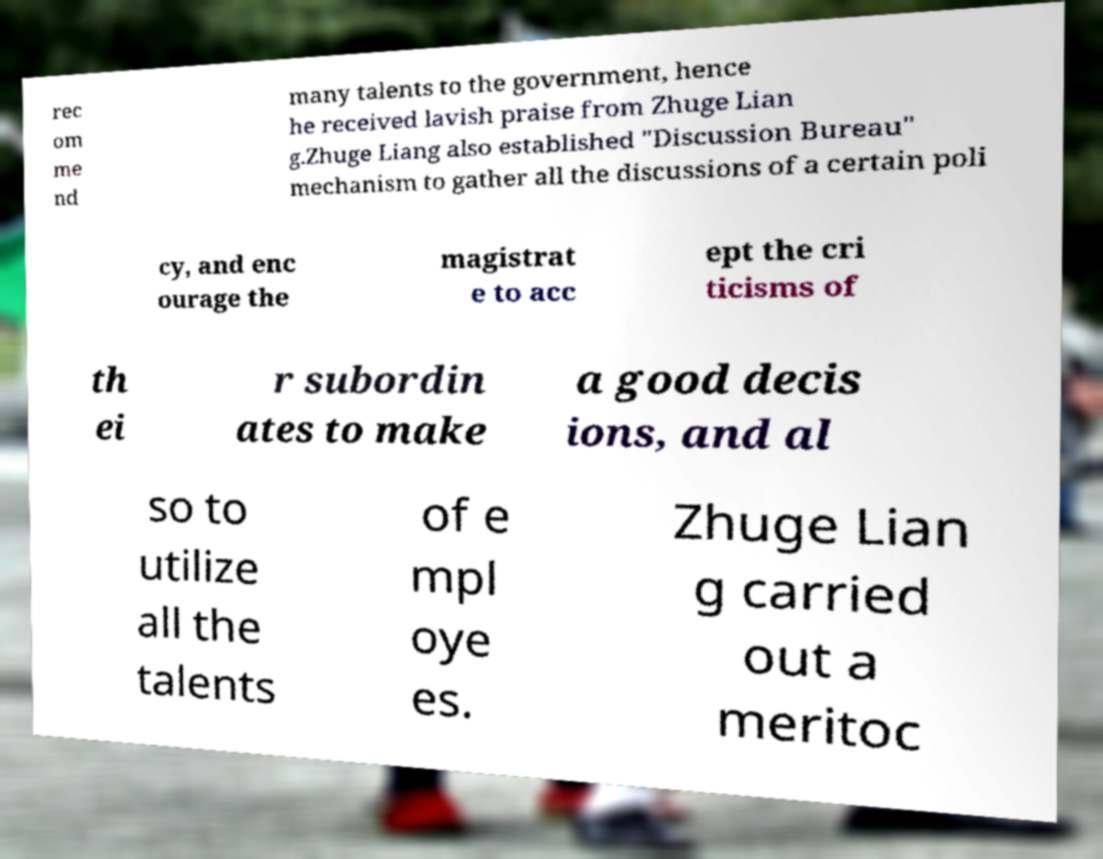There's text embedded in this image that I need extracted. Can you transcribe it verbatim? rec om me nd many talents to the government, hence he received lavish praise from Zhuge Lian g.Zhuge Liang also established "Discussion Bureau" mechanism to gather all the discussions of a certain poli cy, and enc ourage the magistrat e to acc ept the cri ticisms of th ei r subordin ates to make a good decis ions, and al so to utilize all the talents of e mpl oye es. Zhuge Lian g carried out a meritoc 